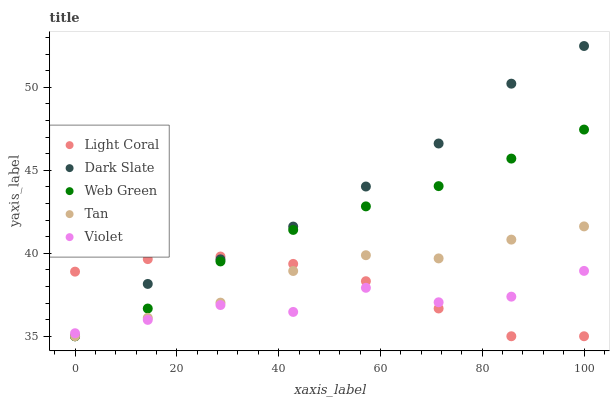Does Violet have the minimum area under the curve?
Answer yes or no. Yes. Does Dark Slate have the maximum area under the curve?
Answer yes or no. Yes. Does Tan have the minimum area under the curve?
Answer yes or no. No. Does Tan have the maximum area under the curve?
Answer yes or no. No. Is Web Green the smoothest?
Answer yes or no. Yes. Is Violet the roughest?
Answer yes or no. Yes. Is Dark Slate the smoothest?
Answer yes or no. No. Is Dark Slate the roughest?
Answer yes or no. No. Does Light Coral have the lowest value?
Answer yes or no. Yes. Does Violet have the lowest value?
Answer yes or no. No. Does Dark Slate have the highest value?
Answer yes or no. Yes. Does Tan have the highest value?
Answer yes or no. No. Does Violet intersect Light Coral?
Answer yes or no. Yes. Is Violet less than Light Coral?
Answer yes or no. No. Is Violet greater than Light Coral?
Answer yes or no. No. 